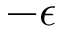Convert formula to latex. <formula><loc_0><loc_0><loc_500><loc_500>- \epsilon</formula> 